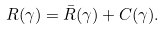<formula> <loc_0><loc_0><loc_500><loc_500>R ( \gamma ) = \bar { R } ( \gamma ) + C ( \gamma ) .</formula> 